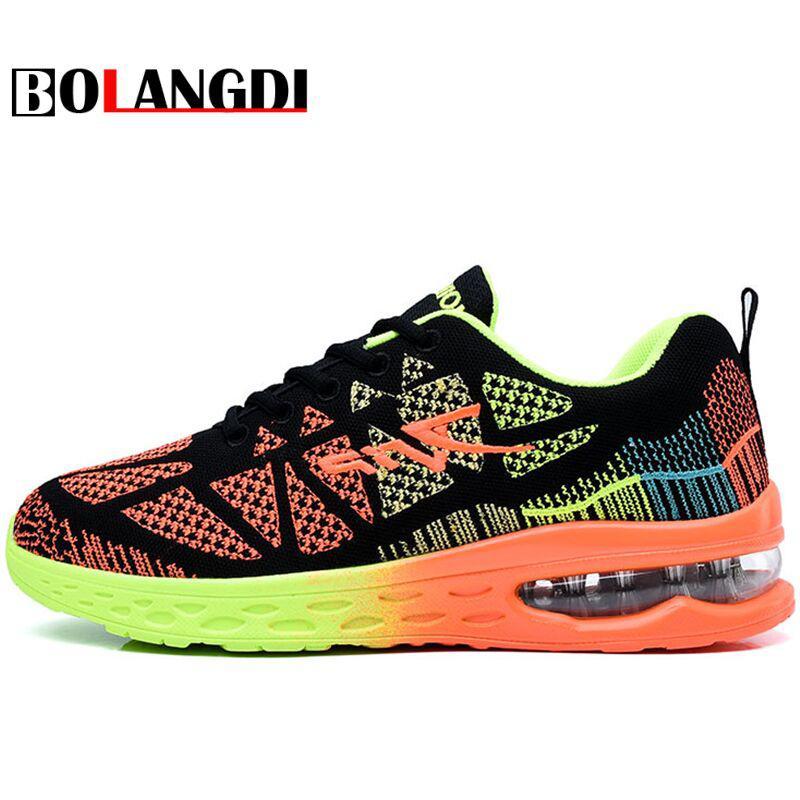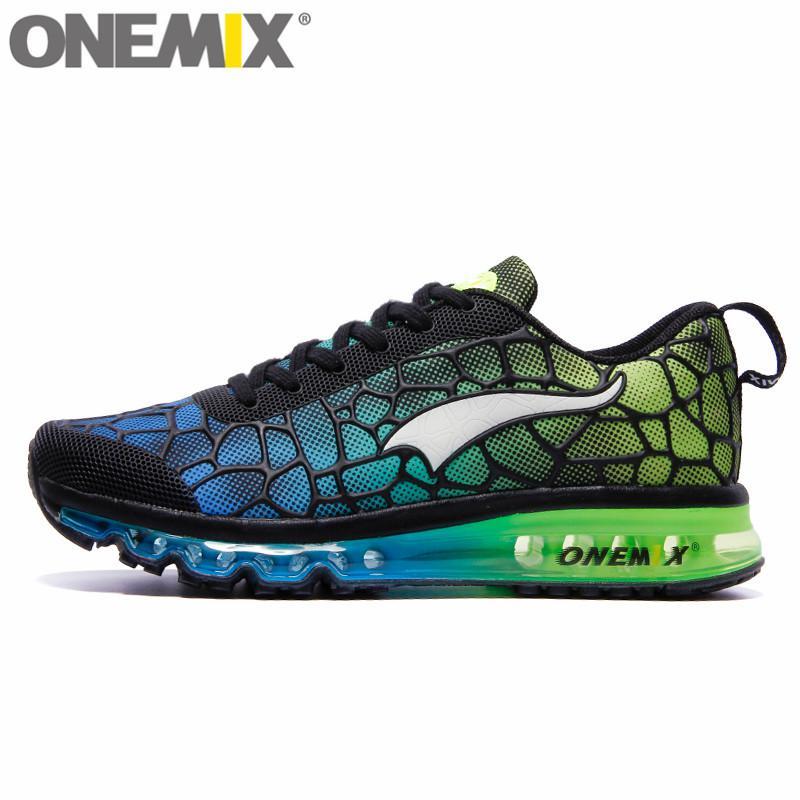The first image is the image on the left, the second image is the image on the right. Evaluate the accuracy of this statement regarding the images: "All shoes are laced with black shoestrings.". Is it true? Answer yes or no. Yes. The first image is the image on the left, the second image is the image on the right. For the images displayed, is the sentence "One shoe has a blue heel." factually correct? Answer yes or no. No. 